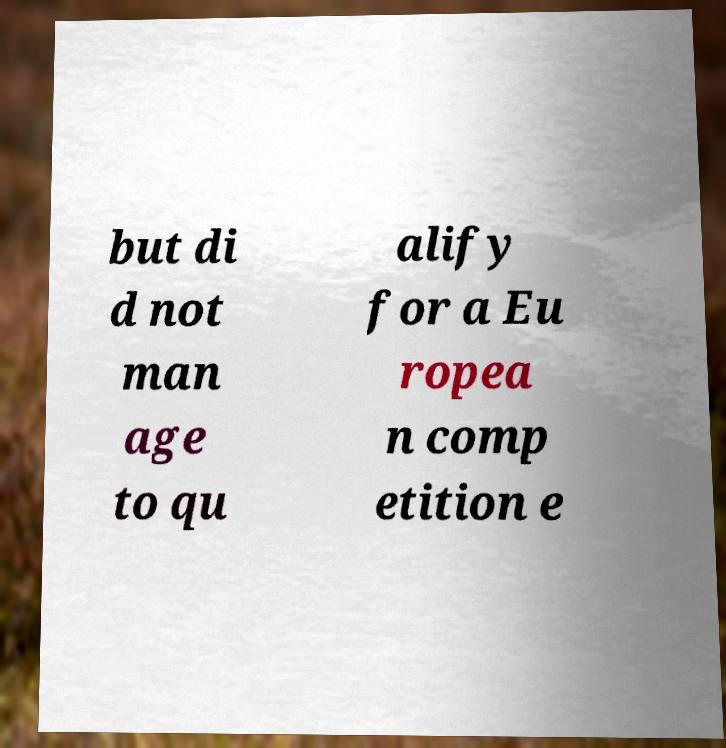Can you accurately transcribe the text from the provided image for me? but di d not man age to qu alify for a Eu ropea n comp etition e 